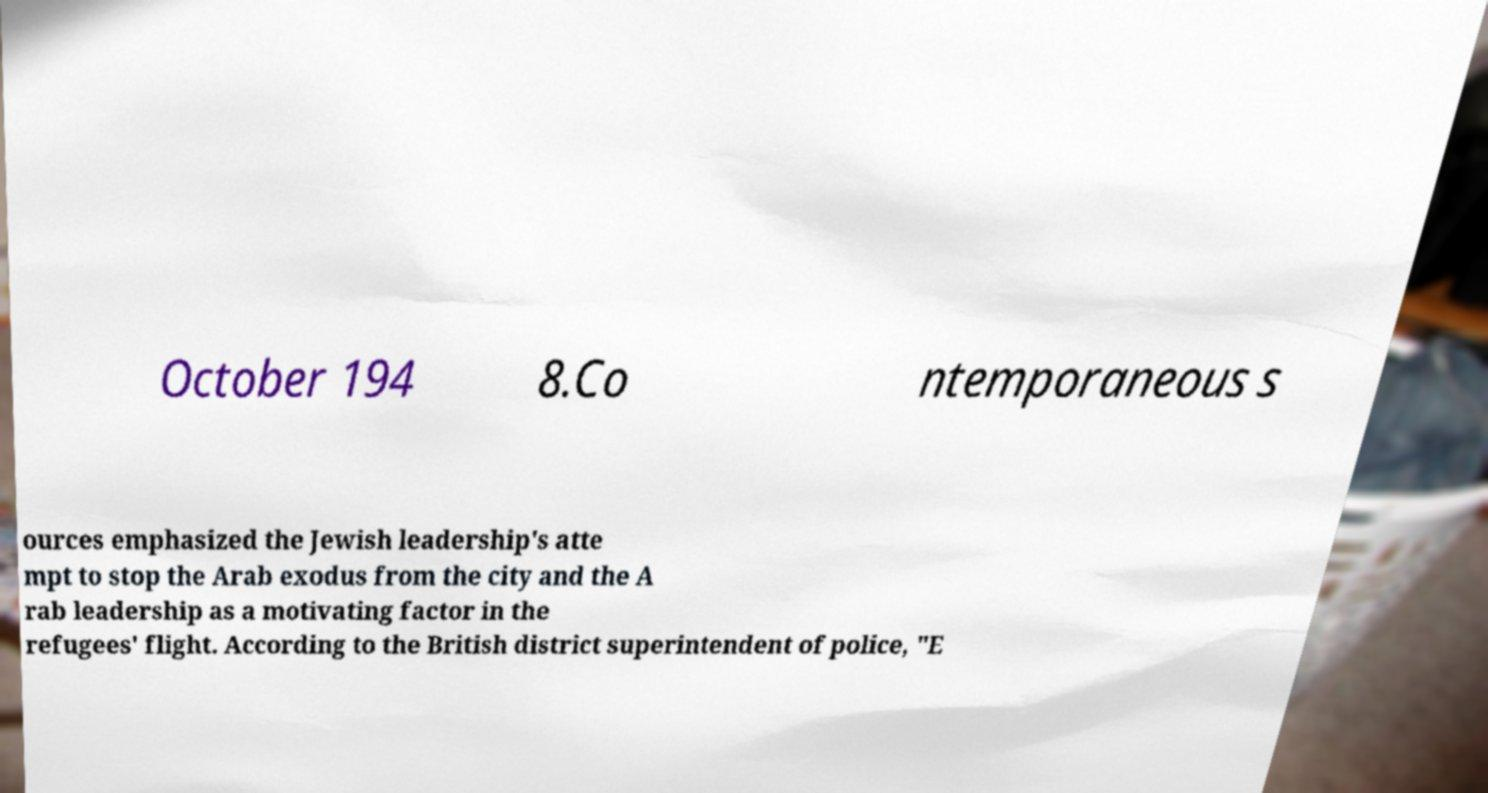I need the written content from this picture converted into text. Can you do that? October 194 8.Co ntemporaneous s ources emphasized the Jewish leadership's atte mpt to stop the Arab exodus from the city and the A rab leadership as a motivating factor in the refugees' flight. According to the British district superintendent of police, "E 